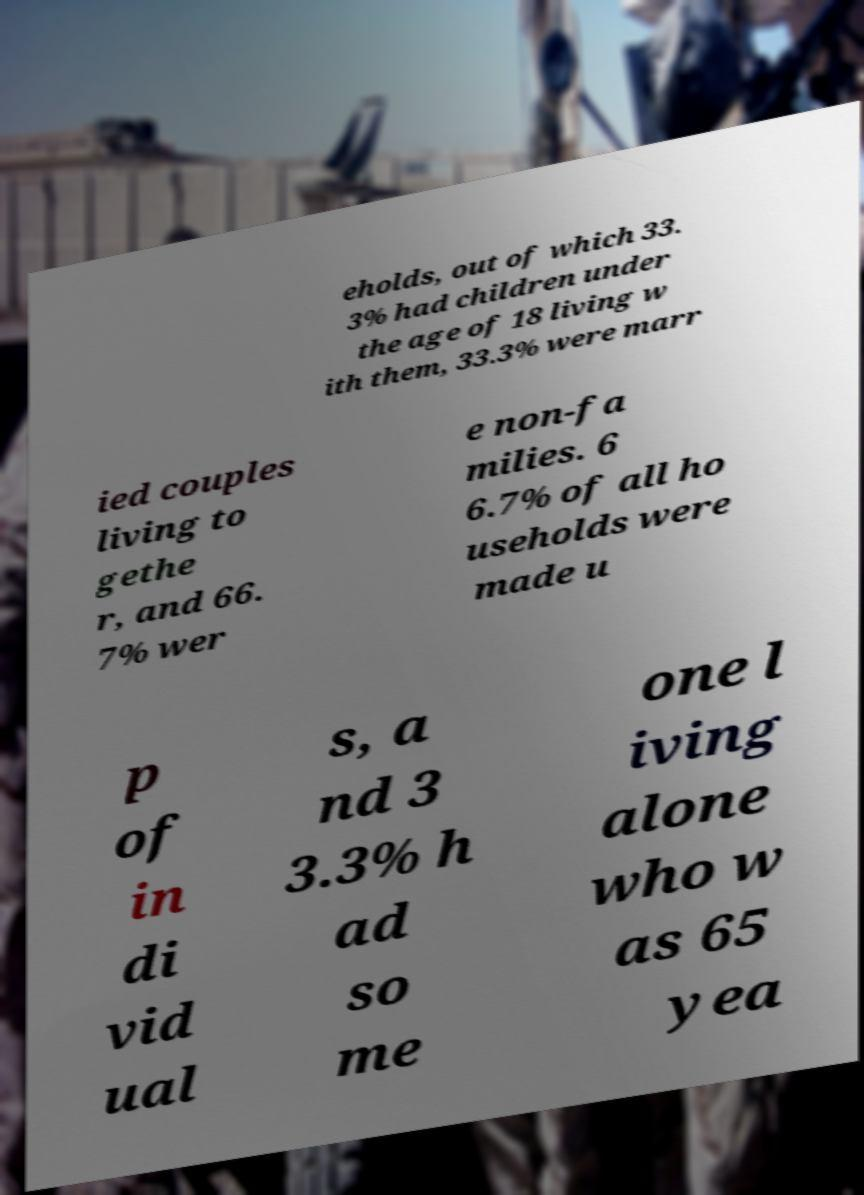Could you assist in decoding the text presented in this image and type it out clearly? eholds, out of which 33. 3% had children under the age of 18 living w ith them, 33.3% were marr ied couples living to gethe r, and 66. 7% wer e non-fa milies. 6 6.7% of all ho useholds were made u p of in di vid ual s, a nd 3 3.3% h ad so me one l iving alone who w as 65 yea 